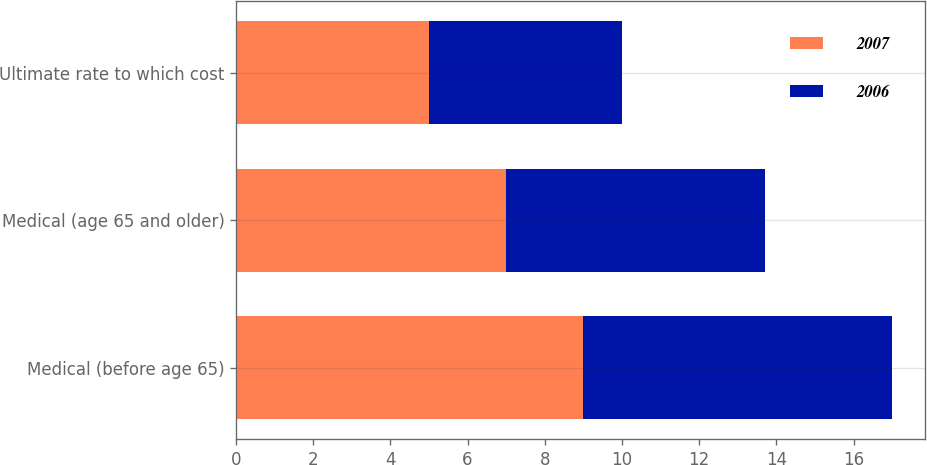Convert chart. <chart><loc_0><loc_0><loc_500><loc_500><stacked_bar_chart><ecel><fcel>Medical (before age 65)<fcel>Medical (age 65 and older)<fcel>Ultimate rate to which cost<nl><fcel>2007<fcel>9<fcel>7<fcel>5<nl><fcel>2006<fcel>8<fcel>6.7<fcel>5<nl></chart> 